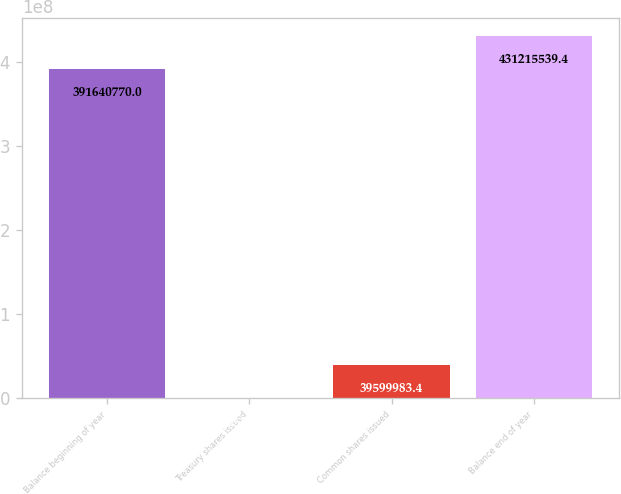Convert chart. <chart><loc_0><loc_0><loc_500><loc_500><bar_chart><fcel>Balance beginning of year<fcel>Treasury shares issued<fcel>Common shares issued<fcel>Balance end of year<nl><fcel>3.91641e+08<fcel>25214<fcel>3.96e+07<fcel>4.31216e+08<nl></chart> 